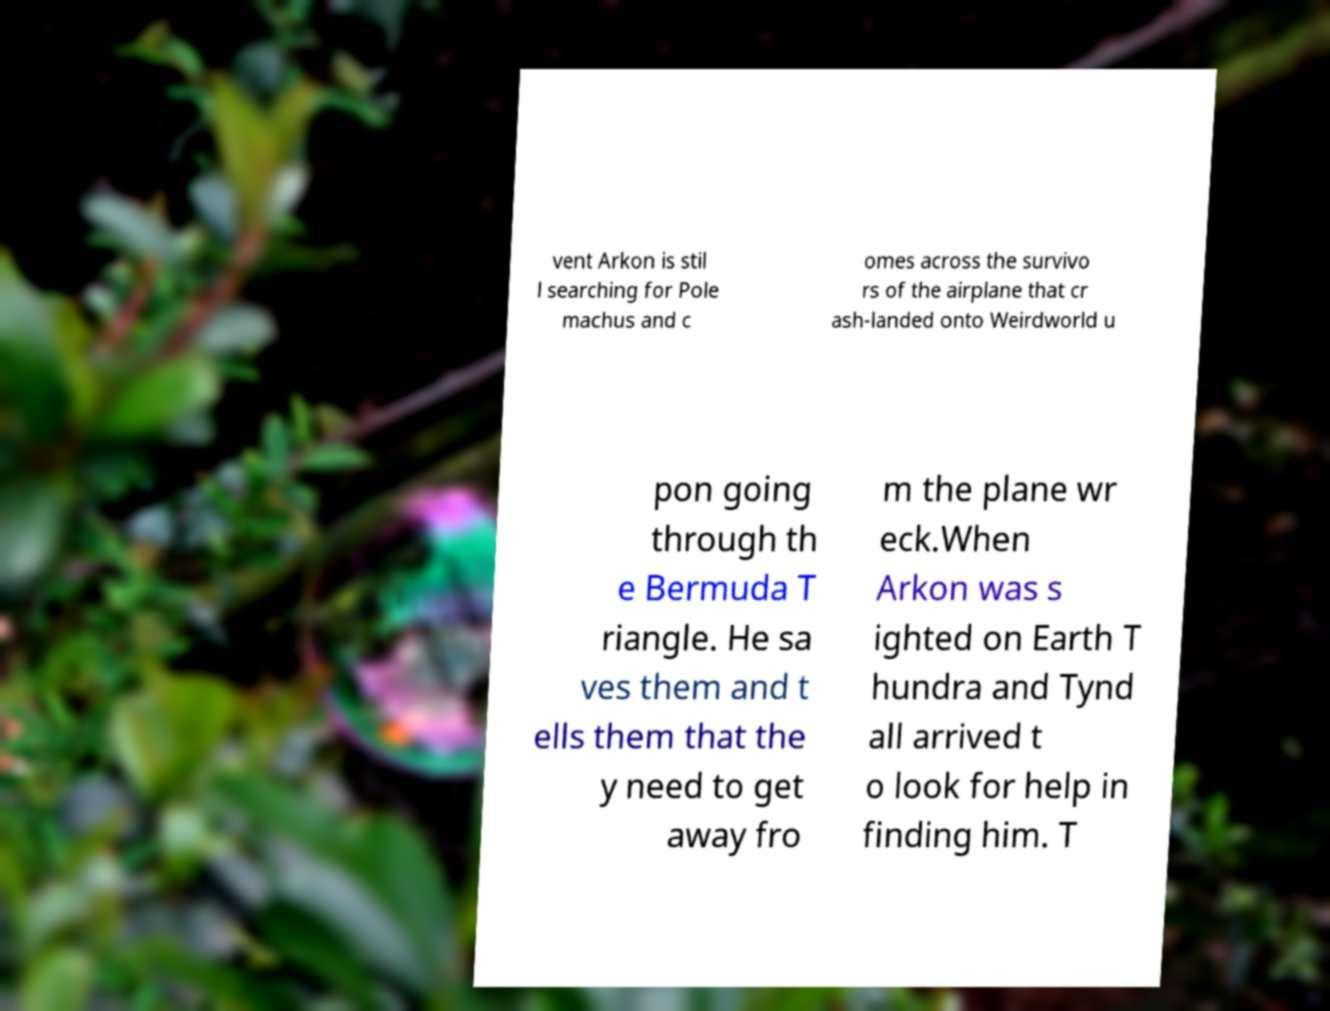Please read and relay the text visible in this image. What does it say? vent Arkon is stil l searching for Pole machus and c omes across the survivo rs of the airplane that cr ash-landed onto Weirdworld u pon going through th e Bermuda T riangle. He sa ves them and t ells them that the y need to get away fro m the plane wr eck.When Arkon was s ighted on Earth T hundra and Tynd all arrived t o look for help in finding him. T 